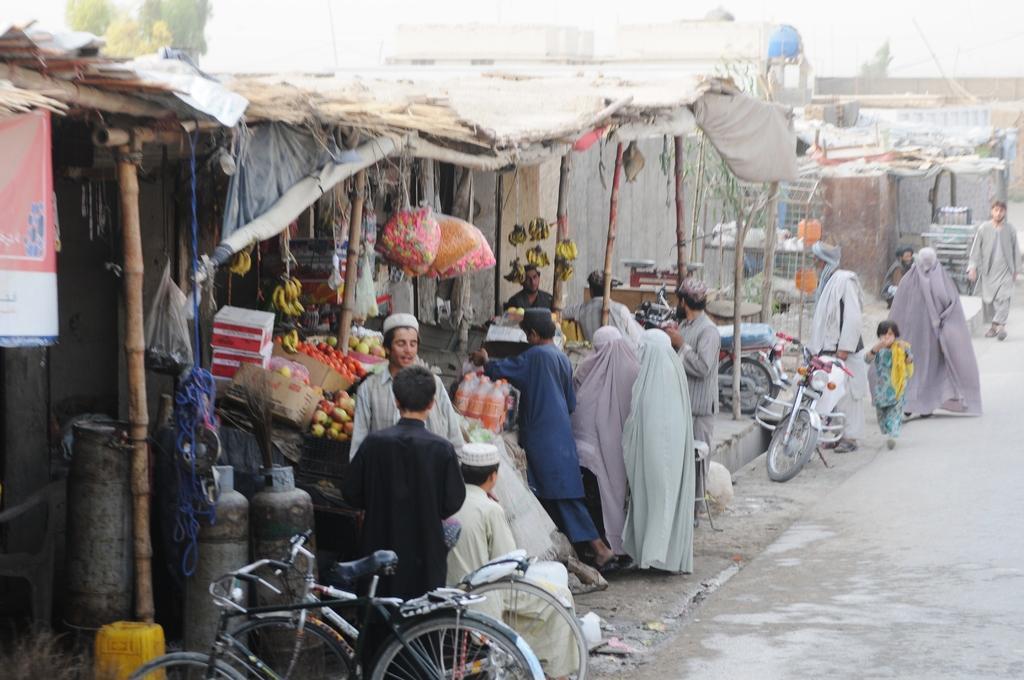Please provide a concise description of this image. In this image, we can see persons wearing clothes. There is a shop in the middle of the image. There are bicycles at the bottom of the image. There are cylinders in the bottom left of the image. There are motorcycles beside the road. 